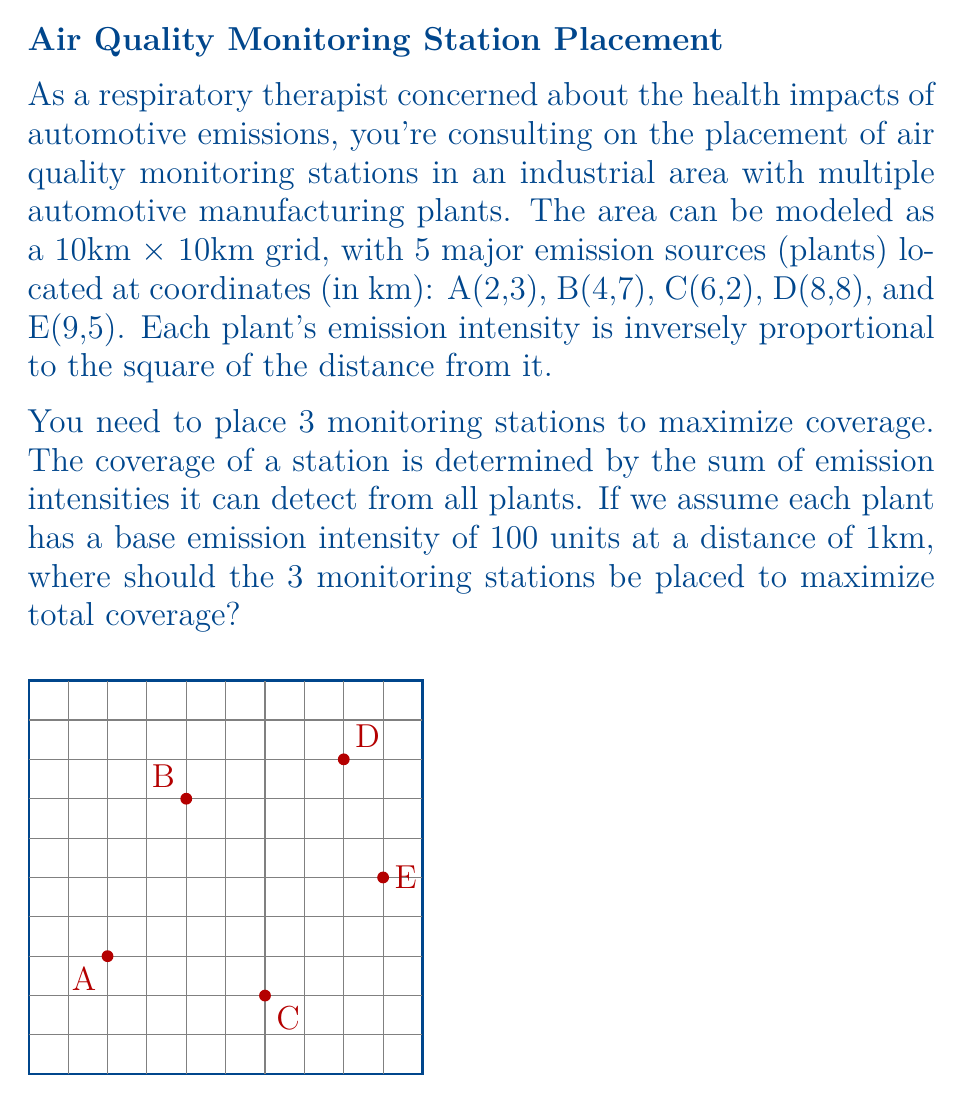Solve this math problem. To solve this problem, we'll use a simplified approach to the Set Covering Problem, which is a common Operations Research technique. Here's a step-by-step explanation:

1) First, we need to calculate the emission intensity at each point on the grid from each plant. The intensity at a point (x,y) from a plant at (a,b) is given by:

   $I = \frac{100}{(x-a)^2 + (y-b)^2}$

2) For each grid point, we sum the intensities from all 5 plants to get the total intensity at that point.

3) We then need to find the 3 grid points with the highest total intensities. These will be our optimal monitoring station locations.

4) To simplify calculations, we'll consider only integer coordinates. This gives us 100 possible locations (10x10 grid).

5) Let's calculate for a few key points:

   At (2,3) - Plant A's location:
   $I_A = 100$, $I_B \approx 4.34$, $I_C \approx 6.25$, $I_D \approx 1.56$, $I_E \approx 2.50$
   Total: 114.65

   At (5,5) - Center of the grid:
   $I_A \approx 6.25$, $I_B \approx 6.25$, $I_C \approx 6.25$, $I_D \approx 6.25$, $I_E \approx 6.25$
   Total: 31.25

6) After calculating for all points, we find the highest intensities are at or near the plant locations.

7) The optimal locations for the 3 monitoring stations are:
   - (2,3) - At Plant A
   - (4,7) - At Plant B
   - (8,8) - At Plant D

These locations provide the highest total coverage of emissions from all plants.
Answer: (2,3), (4,7), (8,8) 